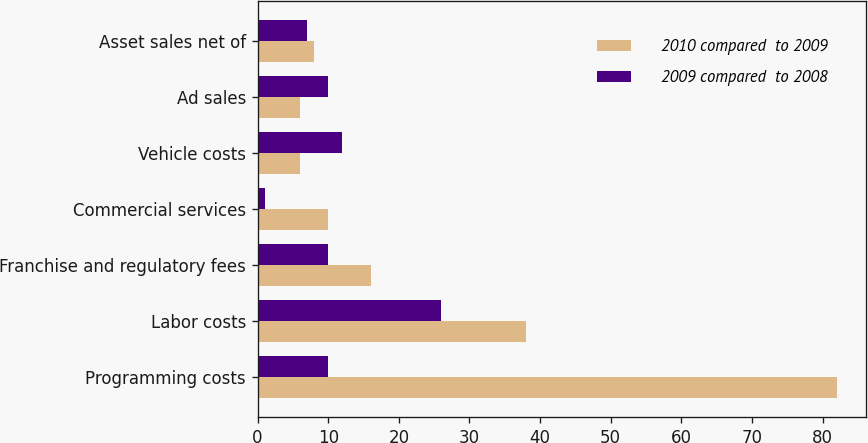Convert chart. <chart><loc_0><loc_0><loc_500><loc_500><stacked_bar_chart><ecel><fcel>Programming costs<fcel>Labor costs<fcel>Franchise and regulatory fees<fcel>Commercial services<fcel>Vehicle costs<fcel>Ad sales<fcel>Asset sales net of<nl><fcel>2010 compared  to 2009<fcel>82<fcel>38<fcel>16<fcel>10<fcel>6<fcel>6<fcel>8<nl><fcel>2009 compared  to 2008<fcel>10<fcel>26<fcel>10<fcel>1<fcel>12<fcel>10<fcel>7<nl></chart> 